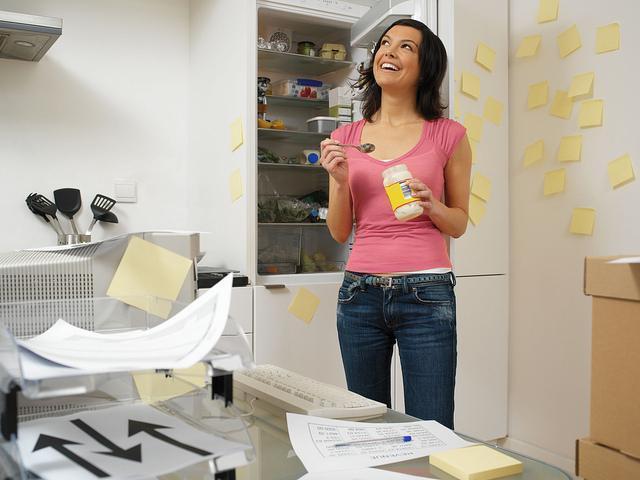How many refrigerators are in the photo?
Give a very brief answer. 1. 